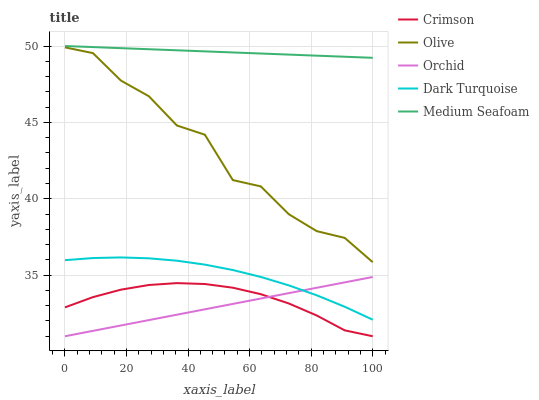Does Orchid have the minimum area under the curve?
Answer yes or no. Yes. Does Medium Seafoam have the maximum area under the curve?
Answer yes or no. Yes. Does Olive have the minimum area under the curve?
Answer yes or no. No. Does Olive have the maximum area under the curve?
Answer yes or no. No. Is Medium Seafoam the smoothest?
Answer yes or no. Yes. Is Olive the roughest?
Answer yes or no. Yes. Is Olive the smoothest?
Answer yes or no. No. Is Medium Seafoam the roughest?
Answer yes or no. No. Does Crimson have the lowest value?
Answer yes or no. Yes. Does Olive have the lowest value?
Answer yes or no. No. Does Medium Seafoam have the highest value?
Answer yes or no. Yes. Does Olive have the highest value?
Answer yes or no. No. Is Crimson less than Dark Turquoise?
Answer yes or no. Yes. Is Olive greater than Dark Turquoise?
Answer yes or no. Yes. Does Crimson intersect Orchid?
Answer yes or no. Yes. Is Crimson less than Orchid?
Answer yes or no. No. Is Crimson greater than Orchid?
Answer yes or no. No. Does Crimson intersect Dark Turquoise?
Answer yes or no. No. 